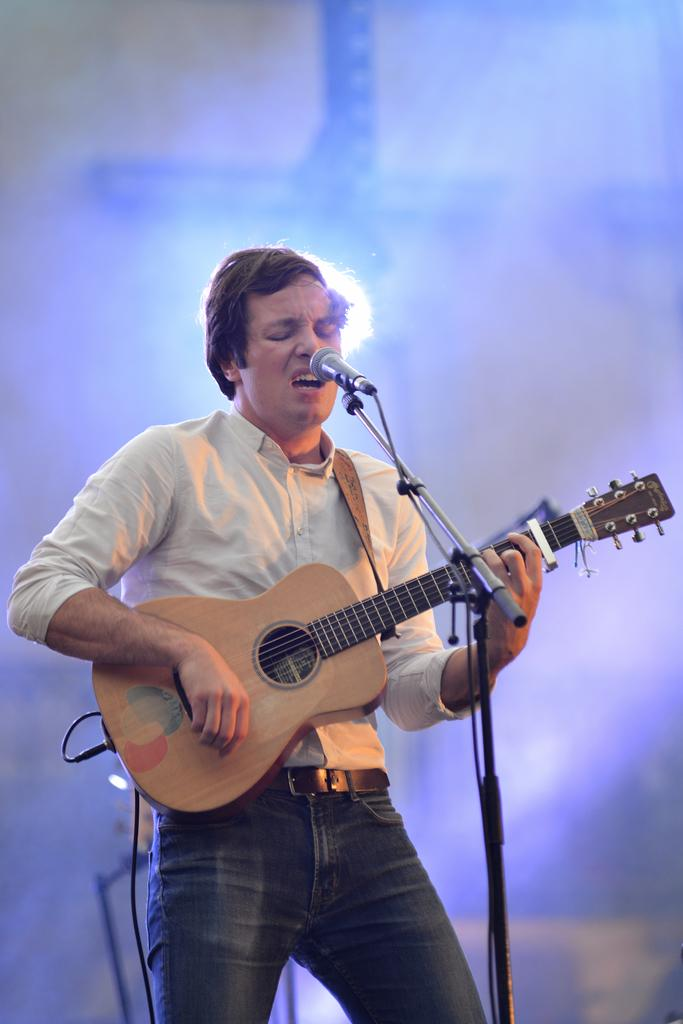What is the main subject of the image? There is a man in the image. What is the man wearing? The man is wearing a white shirt. What is the man doing in the image? The man is standing, playing a guitar, and singing a song. What type of sponge is the man using to clean his teeth in the image? There is no sponge or toothbrush present in the image; the man is playing a guitar and singing a song. 